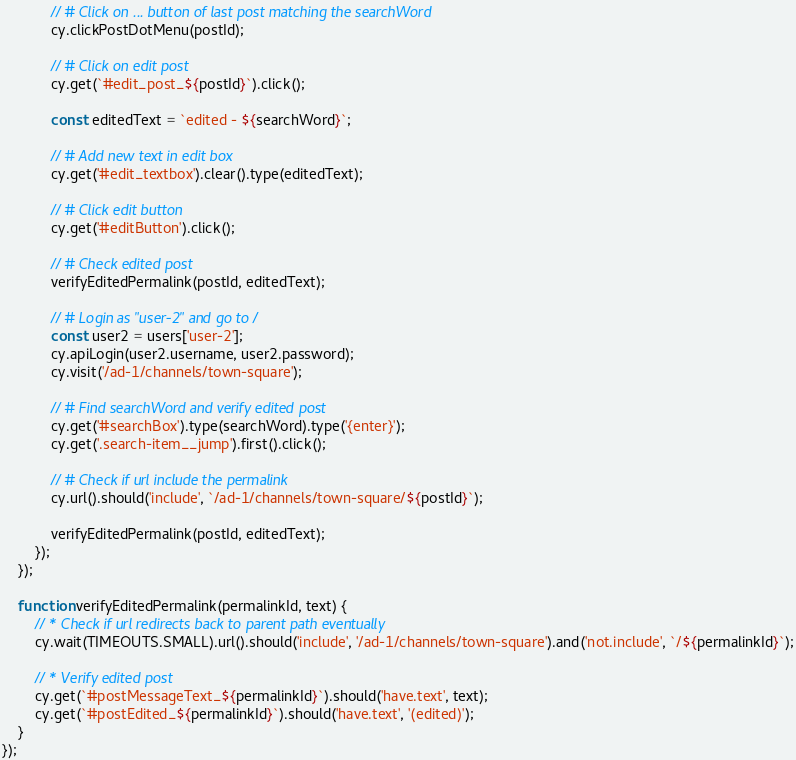Convert code to text. <code><loc_0><loc_0><loc_500><loc_500><_JavaScript_>            // # Click on ... button of last post matching the searchWord
            cy.clickPostDotMenu(postId);

            // # Click on edit post
            cy.get(`#edit_post_${postId}`).click();

            const editedText = `edited - ${searchWord}`;

            // # Add new text in edit box
            cy.get('#edit_textbox').clear().type(editedText);

            // # Click edit button
            cy.get('#editButton').click();

            // # Check edited post
            verifyEditedPermalink(postId, editedText);

            // # Login as "user-2" and go to /
            const user2 = users['user-2'];
            cy.apiLogin(user2.username, user2.password);
            cy.visit('/ad-1/channels/town-square');

            // # Find searchWord and verify edited post
            cy.get('#searchBox').type(searchWord).type('{enter}');
            cy.get('.search-item__jump').first().click();

            // # Check if url include the permalink
            cy.url().should('include', `/ad-1/channels/town-square/${postId}`);

            verifyEditedPermalink(postId, editedText);
        });
    });

    function verifyEditedPermalink(permalinkId, text) {
        // * Check if url redirects back to parent path eventually
        cy.wait(TIMEOUTS.SMALL).url().should('include', '/ad-1/channels/town-square').and('not.include', `/${permalinkId}`);

        // * Verify edited post
        cy.get(`#postMessageText_${permalinkId}`).should('have.text', text);
        cy.get(`#postEdited_${permalinkId}`).should('have.text', '(edited)');
    }
});
</code> 